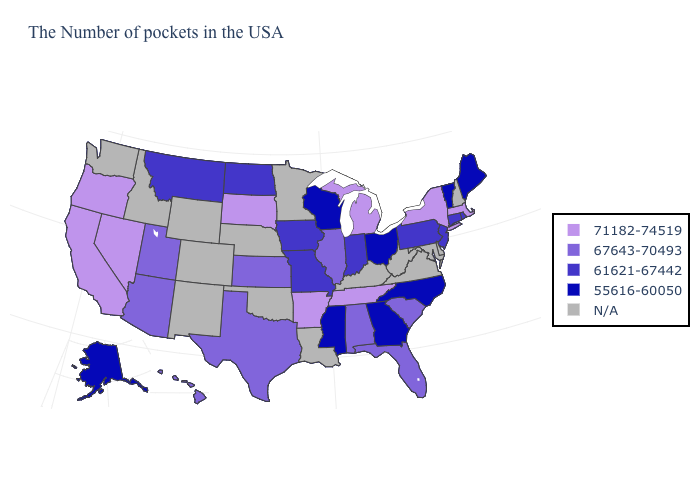Name the states that have a value in the range 61621-67442?
Give a very brief answer. Rhode Island, Connecticut, New Jersey, Pennsylvania, Indiana, Missouri, Iowa, North Dakota, Montana. What is the value of Delaware?
Give a very brief answer. N/A. What is the lowest value in states that border Kentucky?
Quick response, please. 55616-60050. What is the value of South Carolina?
Answer briefly. 67643-70493. Does the first symbol in the legend represent the smallest category?
Concise answer only. No. Name the states that have a value in the range 55616-60050?
Answer briefly. Maine, Vermont, North Carolina, Ohio, Georgia, Wisconsin, Mississippi, Alaska. What is the lowest value in the West?
Be succinct. 55616-60050. What is the highest value in states that border Illinois?
Short answer required. 61621-67442. What is the value of Louisiana?
Give a very brief answer. N/A. How many symbols are there in the legend?
Quick response, please. 5. What is the lowest value in the USA?
Concise answer only. 55616-60050. What is the lowest value in the USA?
Be succinct. 55616-60050. What is the value of Maine?
Concise answer only. 55616-60050. 